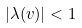<formula> <loc_0><loc_0><loc_500><loc_500>| \lambda ( v ) | < 1</formula> 